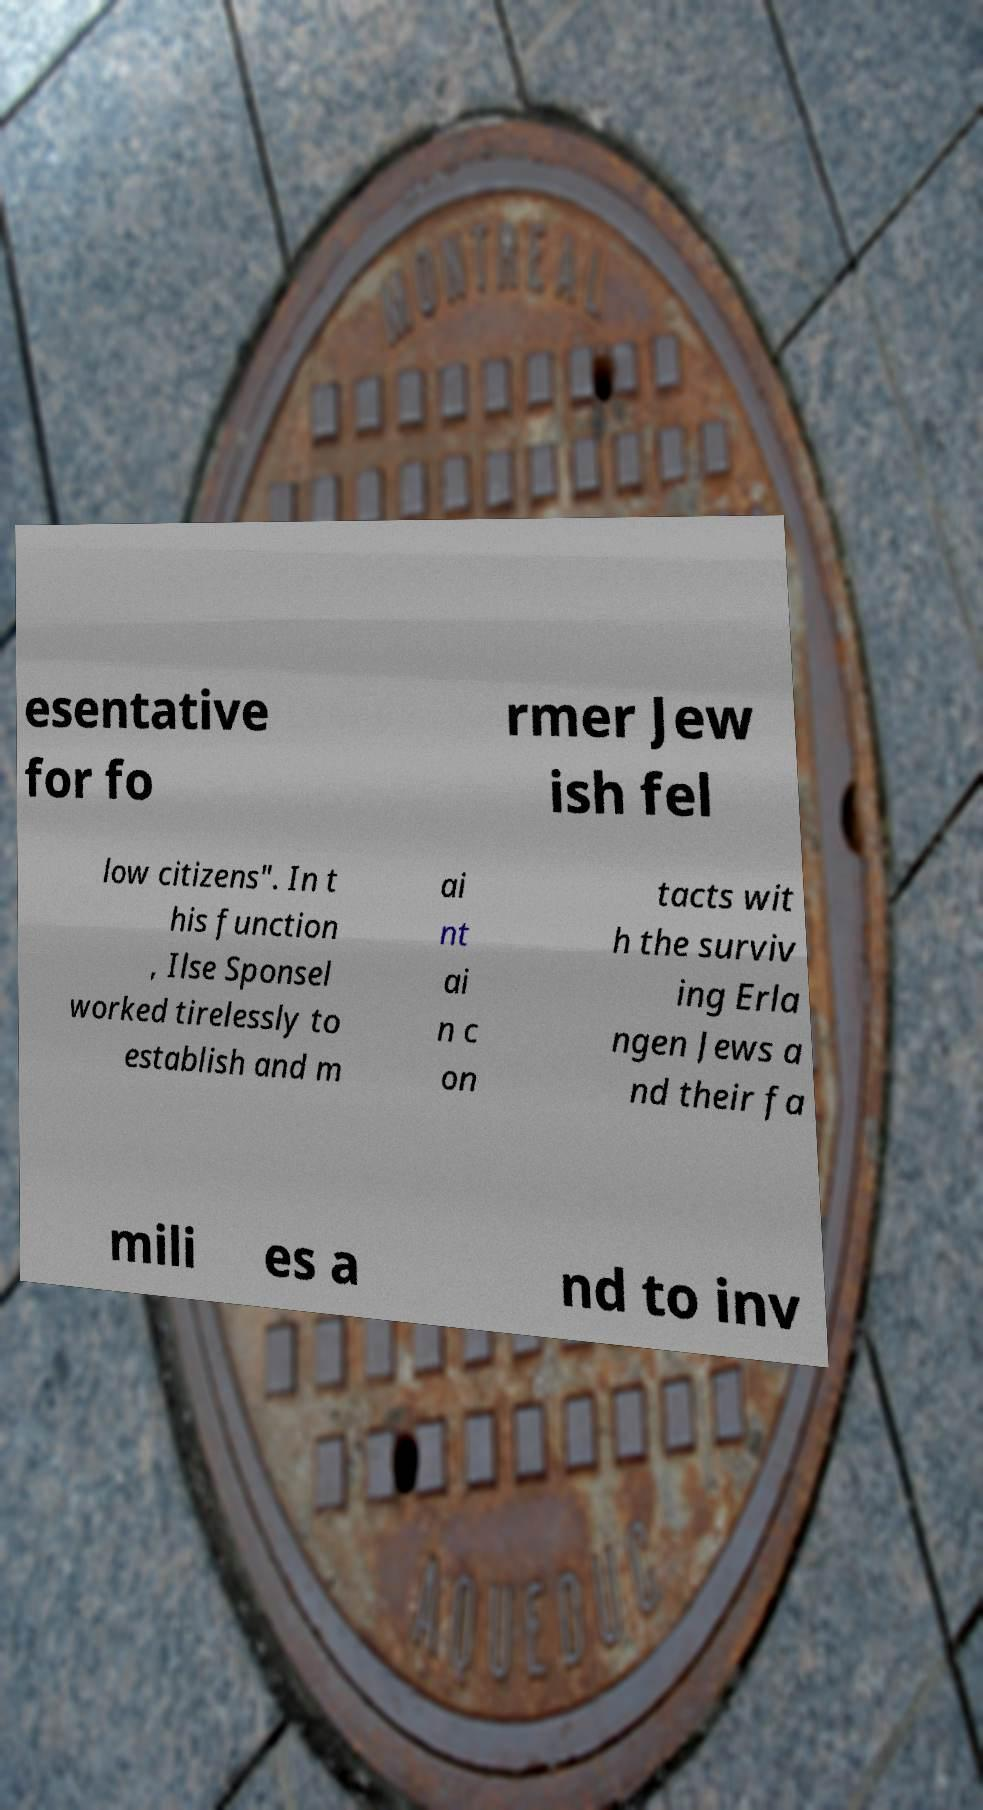Please read and relay the text visible in this image. What does it say? esentative for fo rmer Jew ish fel low citizens". In t his function , Ilse Sponsel worked tirelessly to establish and m ai nt ai n c on tacts wit h the surviv ing Erla ngen Jews a nd their fa mili es a nd to inv 